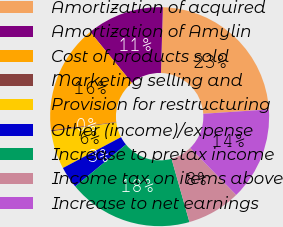Convert chart to OTSL. <chart><loc_0><loc_0><loc_500><loc_500><pie_chart><fcel>Amortization of acquired<fcel>Amortization of Amylin<fcel>Cost of products sold<fcel>Marketing selling and<fcel>Provision for restructuring<fcel>Other (income)/expense<fcel>Increase to pretax income<fcel>Income tax on items above<fcel>Increase to net earnings<nl><fcel>23.47%<fcel>11.4%<fcel>16.06%<fcel>0.17%<fcel>5.61%<fcel>3.23%<fcel>18.39%<fcel>7.94%<fcel>13.73%<nl></chart> 